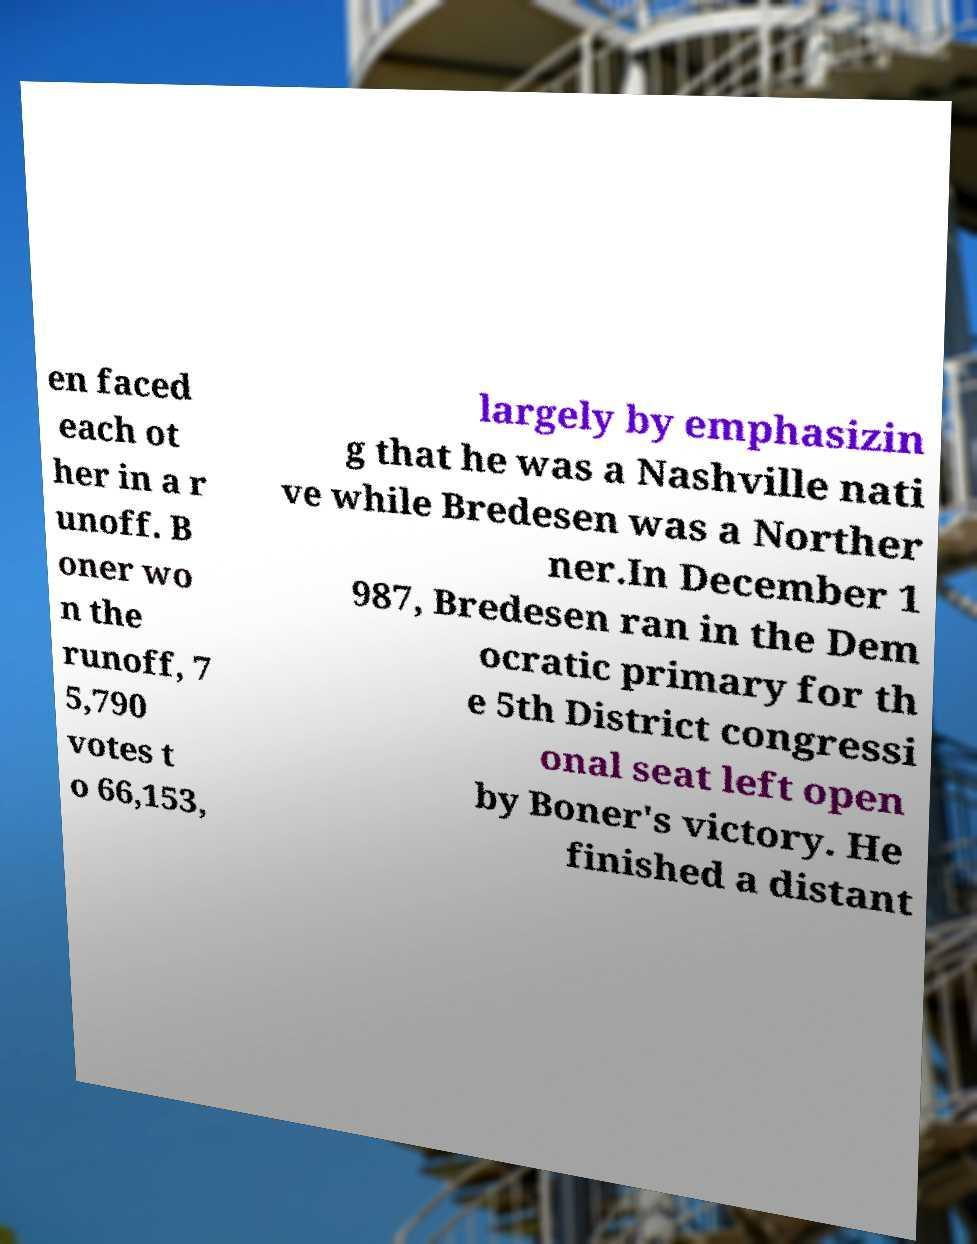For documentation purposes, I need the text within this image transcribed. Could you provide that? en faced each ot her in a r unoff. B oner wo n the runoff, 7 5,790 votes t o 66,153, largely by emphasizin g that he was a Nashville nati ve while Bredesen was a Norther ner.In December 1 987, Bredesen ran in the Dem ocratic primary for th e 5th District congressi onal seat left open by Boner's victory. He finished a distant 